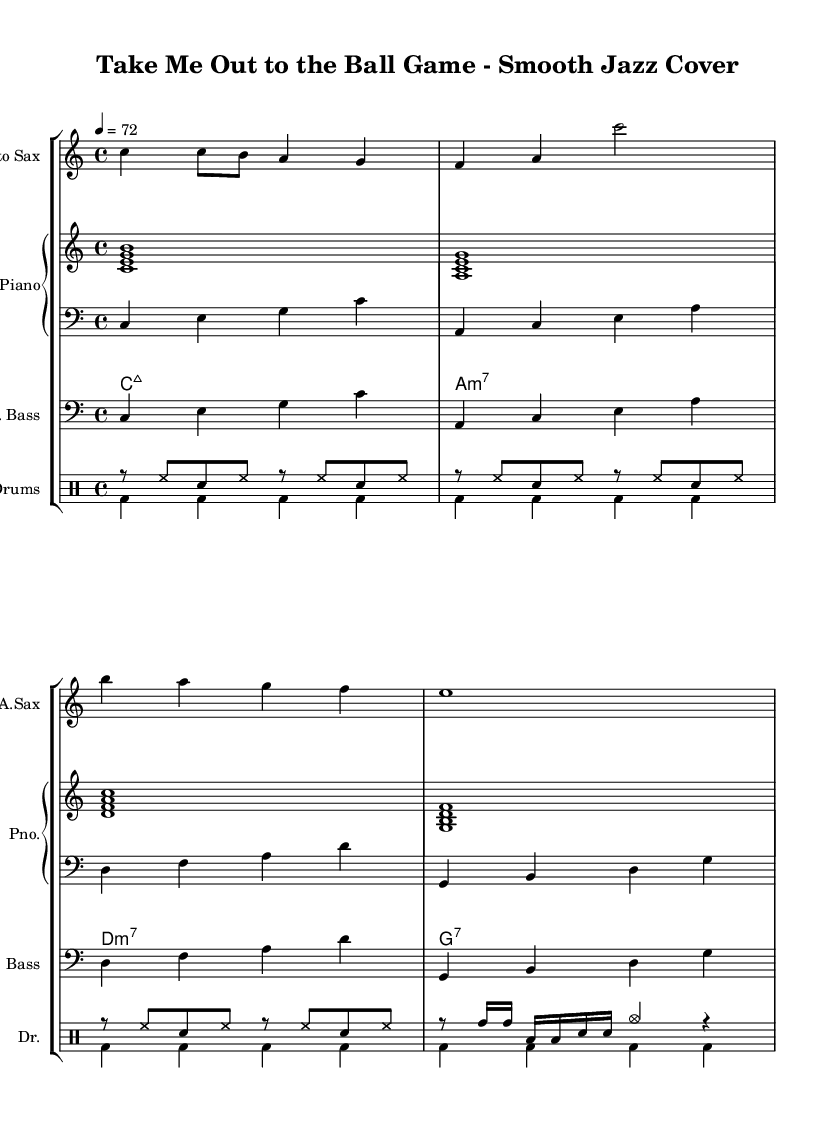What is the key signature of this music? The key signature is indicated at the beginning of the sheet music. Here, it shows no sharps or flats, meaning it is in C major.
Answer: C major What is the time signature of this piece? The time signature is represented by the numbers at the beginning of the sheet music. It shows a 4 on top of a 4, which means four beats per measure in quarter note time.
Answer: 4/4 What is the tempo marking for this music? The tempo marking is indicated by the number at the beginning of the sheet music, which specifies how many beats per minute. Here, it shows a tempo of 72 beats per minute.
Answer: 72 How many measures are in the piece? To find the number of measures, we count the individual measures represented by vertical lines throughout the piece. Here, there are 16 measures in total.
Answer: 16 What is the instrument primarily taking the melody? The instrument playing the melodic line is indicated by the staff names and the notes used. The Alto Saxophone is the instrument that has the melody in this piece.
Answer: Alto Sax What type of chords are used in the piano part? The chords specified in the piano part are indicated in the chord names section. They are major and minor 7th chords, noted with symbols like "maj7" and "min7."
Answer: Major and minor 7th chords Which rhythmic pattern is predominantly used in the drum part? To analyze the drum part, we look at the drummode section. The most frequently used pattern is a combination of hi-hat and snare, depicting a swing-like rhythm typical of jazz.
Answer: Swing-like rhythm 